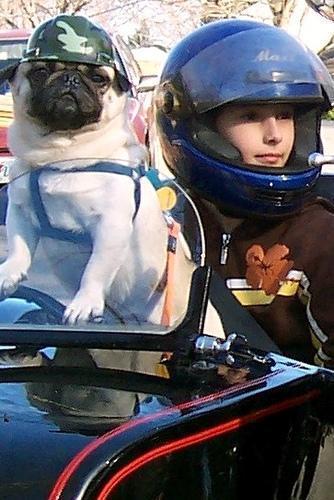How many dogs are there?
Give a very brief answer. 1. How many people are wearing helmets?
Give a very brief answer. 1. How many elephants are standing on two legs?
Give a very brief answer. 0. 